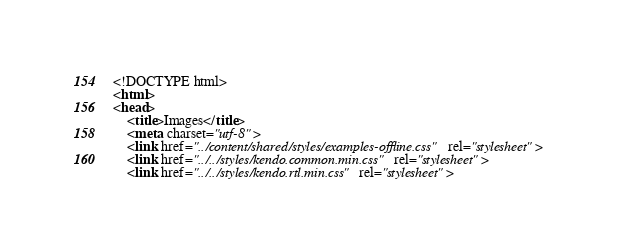Convert code to text. <code><loc_0><loc_0><loc_500><loc_500><_HTML_><!DOCTYPE html>
<html>
<head>
    <title>Images</title>
    <meta charset="utf-8">
    <link href="../content/shared/styles/examples-offline.css" rel="stylesheet">
    <link href="../../styles/kendo.common.min.css" rel="stylesheet">
    <link href="../../styles/kendo.rtl.min.css" rel="stylesheet"></code> 